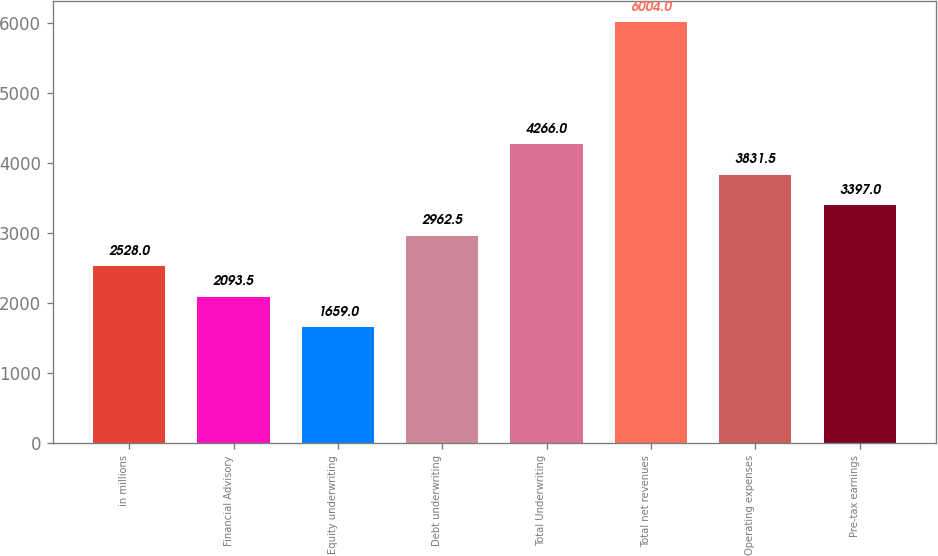Convert chart. <chart><loc_0><loc_0><loc_500><loc_500><bar_chart><fcel>in millions<fcel>Financial Advisory<fcel>Equity underwriting<fcel>Debt underwriting<fcel>Total Underwriting<fcel>Total net revenues<fcel>Operating expenses<fcel>Pre-tax earnings<nl><fcel>2528<fcel>2093.5<fcel>1659<fcel>2962.5<fcel>4266<fcel>6004<fcel>3831.5<fcel>3397<nl></chart> 